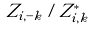Convert formula to latex. <formula><loc_0><loc_0><loc_500><loc_500>Z _ { i , - k } / Z _ { i , k } ^ { * }</formula> 